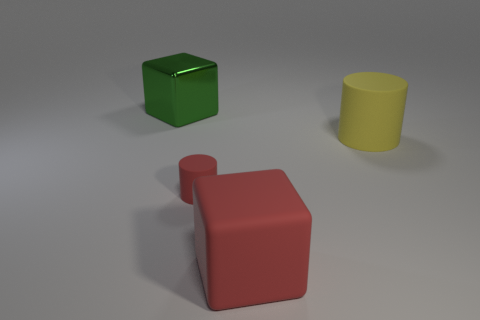Subtract all green cubes. How many cubes are left? 1 Add 2 gray rubber objects. How many objects exist? 6 Subtract 1 blocks. How many blocks are left? 1 Subtract all cyan cylinders. Subtract all cyan spheres. How many cylinders are left? 2 Subtract all purple cubes. How many yellow cylinders are left? 1 Subtract all tiny red rubber cylinders. Subtract all big yellow balls. How many objects are left? 3 Add 3 big rubber things. How many big rubber things are left? 5 Add 2 small green rubber objects. How many small green rubber objects exist? 2 Subtract 1 red cylinders. How many objects are left? 3 